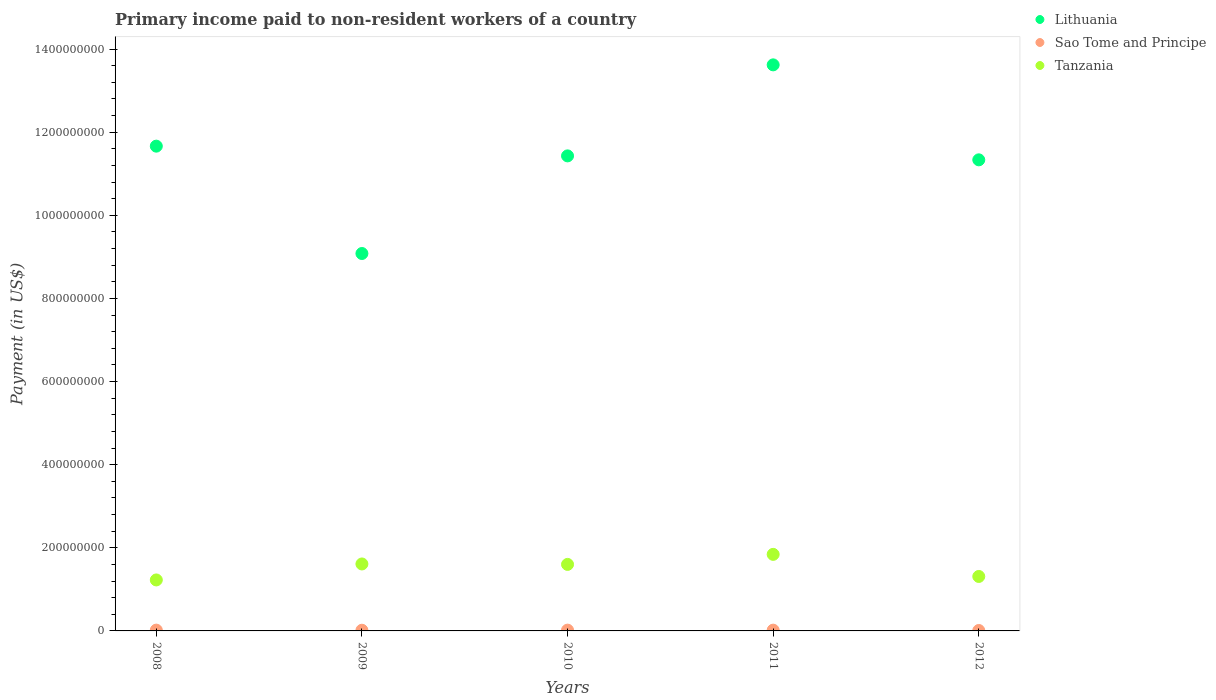Is the number of dotlines equal to the number of legend labels?
Your response must be concise. Yes. What is the amount paid to workers in Lithuania in 2009?
Offer a terse response. 9.08e+08. Across all years, what is the maximum amount paid to workers in Lithuania?
Offer a very short reply. 1.36e+09. Across all years, what is the minimum amount paid to workers in Sao Tome and Principe?
Make the answer very short. 1.02e+06. In which year was the amount paid to workers in Sao Tome and Principe maximum?
Provide a short and direct response. 2008. In which year was the amount paid to workers in Lithuania minimum?
Your answer should be very brief. 2009. What is the total amount paid to workers in Lithuania in the graph?
Provide a succinct answer. 5.71e+09. What is the difference between the amount paid to workers in Lithuania in 2008 and that in 2011?
Your answer should be compact. -1.96e+08. What is the difference between the amount paid to workers in Lithuania in 2008 and the amount paid to workers in Sao Tome and Principe in 2009?
Your response must be concise. 1.16e+09. What is the average amount paid to workers in Tanzania per year?
Your answer should be compact. 1.52e+08. In the year 2009, what is the difference between the amount paid to workers in Tanzania and amount paid to workers in Lithuania?
Offer a very short reply. -7.47e+08. In how many years, is the amount paid to workers in Tanzania greater than 80000000 US$?
Give a very brief answer. 5. What is the ratio of the amount paid to workers in Sao Tome and Principe in 2010 to that in 2012?
Provide a succinct answer. 1.86. Is the difference between the amount paid to workers in Tanzania in 2009 and 2012 greater than the difference between the amount paid to workers in Lithuania in 2009 and 2012?
Make the answer very short. Yes. What is the difference between the highest and the second highest amount paid to workers in Lithuania?
Give a very brief answer. 1.96e+08. What is the difference between the highest and the lowest amount paid to workers in Tanzania?
Make the answer very short. 6.15e+07. In how many years, is the amount paid to workers in Tanzania greater than the average amount paid to workers in Tanzania taken over all years?
Your answer should be compact. 3. Is the amount paid to workers in Lithuania strictly less than the amount paid to workers in Sao Tome and Principe over the years?
Your answer should be very brief. No. How many dotlines are there?
Your answer should be compact. 3. How many years are there in the graph?
Provide a succinct answer. 5. Does the graph contain grids?
Offer a terse response. No. Where does the legend appear in the graph?
Ensure brevity in your answer.  Top right. What is the title of the graph?
Provide a short and direct response. Primary income paid to non-resident workers of a country. What is the label or title of the X-axis?
Make the answer very short. Years. What is the label or title of the Y-axis?
Your answer should be very brief. Payment (in US$). What is the Payment (in US$) in Lithuania in 2008?
Make the answer very short. 1.17e+09. What is the Payment (in US$) of Sao Tome and Principe in 2008?
Keep it short and to the point. 1.94e+06. What is the Payment (in US$) in Tanzania in 2008?
Offer a very short reply. 1.23e+08. What is the Payment (in US$) of Lithuania in 2009?
Keep it short and to the point. 9.08e+08. What is the Payment (in US$) in Sao Tome and Principe in 2009?
Your answer should be compact. 1.64e+06. What is the Payment (in US$) of Tanzania in 2009?
Offer a terse response. 1.61e+08. What is the Payment (in US$) in Lithuania in 2010?
Provide a short and direct response. 1.14e+09. What is the Payment (in US$) of Sao Tome and Principe in 2010?
Ensure brevity in your answer.  1.89e+06. What is the Payment (in US$) of Tanzania in 2010?
Offer a terse response. 1.60e+08. What is the Payment (in US$) of Lithuania in 2011?
Keep it short and to the point. 1.36e+09. What is the Payment (in US$) of Sao Tome and Principe in 2011?
Provide a succinct answer. 1.87e+06. What is the Payment (in US$) in Tanzania in 2011?
Your response must be concise. 1.84e+08. What is the Payment (in US$) of Lithuania in 2012?
Offer a very short reply. 1.13e+09. What is the Payment (in US$) of Sao Tome and Principe in 2012?
Your answer should be very brief. 1.02e+06. What is the Payment (in US$) in Tanzania in 2012?
Provide a short and direct response. 1.31e+08. Across all years, what is the maximum Payment (in US$) of Lithuania?
Provide a succinct answer. 1.36e+09. Across all years, what is the maximum Payment (in US$) in Sao Tome and Principe?
Your answer should be very brief. 1.94e+06. Across all years, what is the maximum Payment (in US$) in Tanzania?
Ensure brevity in your answer.  1.84e+08. Across all years, what is the minimum Payment (in US$) in Lithuania?
Your response must be concise. 9.08e+08. Across all years, what is the minimum Payment (in US$) in Sao Tome and Principe?
Offer a very short reply. 1.02e+06. Across all years, what is the minimum Payment (in US$) of Tanzania?
Make the answer very short. 1.23e+08. What is the total Payment (in US$) in Lithuania in the graph?
Offer a very short reply. 5.71e+09. What is the total Payment (in US$) in Sao Tome and Principe in the graph?
Provide a short and direct response. 8.37e+06. What is the total Payment (in US$) of Tanzania in the graph?
Give a very brief answer. 7.59e+08. What is the difference between the Payment (in US$) of Lithuania in 2008 and that in 2009?
Your response must be concise. 2.58e+08. What is the difference between the Payment (in US$) in Sao Tome and Principe in 2008 and that in 2009?
Your answer should be compact. 2.96e+05. What is the difference between the Payment (in US$) in Tanzania in 2008 and that in 2009?
Ensure brevity in your answer.  -3.85e+07. What is the difference between the Payment (in US$) in Lithuania in 2008 and that in 2010?
Ensure brevity in your answer.  2.34e+07. What is the difference between the Payment (in US$) in Sao Tome and Principe in 2008 and that in 2010?
Offer a terse response. 4.46e+04. What is the difference between the Payment (in US$) of Tanzania in 2008 and that in 2010?
Give a very brief answer. -3.74e+07. What is the difference between the Payment (in US$) of Lithuania in 2008 and that in 2011?
Make the answer very short. -1.96e+08. What is the difference between the Payment (in US$) in Sao Tome and Principe in 2008 and that in 2011?
Provide a short and direct response. 7.24e+04. What is the difference between the Payment (in US$) in Tanzania in 2008 and that in 2011?
Offer a very short reply. -6.15e+07. What is the difference between the Payment (in US$) in Lithuania in 2008 and that in 2012?
Keep it short and to the point. 3.29e+07. What is the difference between the Payment (in US$) in Sao Tome and Principe in 2008 and that in 2012?
Keep it short and to the point. 9.18e+05. What is the difference between the Payment (in US$) of Tanzania in 2008 and that in 2012?
Make the answer very short. -8.38e+06. What is the difference between the Payment (in US$) in Lithuania in 2009 and that in 2010?
Provide a short and direct response. -2.35e+08. What is the difference between the Payment (in US$) in Sao Tome and Principe in 2009 and that in 2010?
Make the answer very short. -2.51e+05. What is the difference between the Payment (in US$) in Tanzania in 2009 and that in 2010?
Offer a terse response. 1.07e+06. What is the difference between the Payment (in US$) in Lithuania in 2009 and that in 2011?
Keep it short and to the point. -4.54e+08. What is the difference between the Payment (in US$) in Sao Tome and Principe in 2009 and that in 2011?
Ensure brevity in your answer.  -2.24e+05. What is the difference between the Payment (in US$) of Tanzania in 2009 and that in 2011?
Provide a short and direct response. -2.31e+07. What is the difference between the Payment (in US$) in Lithuania in 2009 and that in 2012?
Offer a very short reply. -2.25e+08. What is the difference between the Payment (in US$) in Sao Tome and Principe in 2009 and that in 2012?
Your response must be concise. 6.22e+05. What is the difference between the Payment (in US$) in Tanzania in 2009 and that in 2012?
Offer a very short reply. 3.01e+07. What is the difference between the Payment (in US$) of Lithuania in 2010 and that in 2011?
Provide a succinct answer. -2.19e+08. What is the difference between the Payment (in US$) in Sao Tome and Principe in 2010 and that in 2011?
Ensure brevity in your answer.  2.78e+04. What is the difference between the Payment (in US$) of Tanzania in 2010 and that in 2011?
Offer a very short reply. -2.41e+07. What is the difference between the Payment (in US$) of Lithuania in 2010 and that in 2012?
Your answer should be very brief. 9.50e+06. What is the difference between the Payment (in US$) of Sao Tome and Principe in 2010 and that in 2012?
Keep it short and to the point. 8.74e+05. What is the difference between the Payment (in US$) in Tanzania in 2010 and that in 2012?
Your answer should be very brief. 2.90e+07. What is the difference between the Payment (in US$) of Lithuania in 2011 and that in 2012?
Make the answer very short. 2.29e+08. What is the difference between the Payment (in US$) in Sao Tome and Principe in 2011 and that in 2012?
Your answer should be compact. 8.46e+05. What is the difference between the Payment (in US$) of Tanzania in 2011 and that in 2012?
Make the answer very short. 5.31e+07. What is the difference between the Payment (in US$) in Lithuania in 2008 and the Payment (in US$) in Sao Tome and Principe in 2009?
Keep it short and to the point. 1.16e+09. What is the difference between the Payment (in US$) in Lithuania in 2008 and the Payment (in US$) in Tanzania in 2009?
Your response must be concise. 1.01e+09. What is the difference between the Payment (in US$) in Sao Tome and Principe in 2008 and the Payment (in US$) in Tanzania in 2009?
Your response must be concise. -1.59e+08. What is the difference between the Payment (in US$) of Lithuania in 2008 and the Payment (in US$) of Sao Tome and Principe in 2010?
Your answer should be compact. 1.16e+09. What is the difference between the Payment (in US$) in Lithuania in 2008 and the Payment (in US$) in Tanzania in 2010?
Offer a very short reply. 1.01e+09. What is the difference between the Payment (in US$) in Sao Tome and Principe in 2008 and the Payment (in US$) in Tanzania in 2010?
Ensure brevity in your answer.  -1.58e+08. What is the difference between the Payment (in US$) of Lithuania in 2008 and the Payment (in US$) of Sao Tome and Principe in 2011?
Your answer should be very brief. 1.16e+09. What is the difference between the Payment (in US$) of Lithuania in 2008 and the Payment (in US$) of Tanzania in 2011?
Make the answer very short. 9.82e+08. What is the difference between the Payment (in US$) in Sao Tome and Principe in 2008 and the Payment (in US$) in Tanzania in 2011?
Ensure brevity in your answer.  -1.82e+08. What is the difference between the Payment (in US$) of Lithuania in 2008 and the Payment (in US$) of Sao Tome and Principe in 2012?
Ensure brevity in your answer.  1.17e+09. What is the difference between the Payment (in US$) in Lithuania in 2008 and the Payment (in US$) in Tanzania in 2012?
Ensure brevity in your answer.  1.04e+09. What is the difference between the Payment (in US$) in Sao Tome and Principe in 2008 and the Payment (in US$) in Tanzania in 2012?
Give a very brief answer. -1.29e+08. What is the difference between the Payment (in US$) of Lithuania in 2009 and the Payment (in US$) of Sao Tome and Principe in 2010?
Your answer should be very brief. 9.06e+08. What is the difference between the Payment (in US$) of Lithuania in 2009 and the Payment (in US$) of Tanzania in 2010?
Your answer should be very brief. 7.48e+08. What is the difference between the Payment (in US$) of Sao Tome and Principe in 2009 and the Payment (in US$) of Tanzania in 2010?
Make the answer very short. -1.58e+08. What is the difference between the Payment (in US$) of Lithuania in 2009 and the Payment (in US$) of Sao Tome and Principe in 2011?
Provide a succinct answer. 9.06e+08. What is the difference between the Payment (in US$) in Lithuania in 2009 and the Payment (in US$) in Tanzania in 2011?
Keep it short and to the point. 7.24e+08. What is the difference between the Payment (in US$) in Sao Tome and Principe in 2009 and the Payment (in US$) in Tanzania in 2011?
Keep it short and to the point. -1.83e+08. What is the difference between the Payment (in US$) of Lithuania in 2009 and the Payment (in US$) of Sao Tome and Principe in 2012?
Make the answer very short. 9.07e+08. What is the difference between the Payment (in US$) of Lithuania in 2009 and the Payment (in US$) of Tanzania in 2012?
Offer a very short reply. 7.77e+08. What is the difference between the Payment (in US$) of Sao Tome and Principe in 2009 and the Payment (in US$) of Tanzania in 2012?
Your response must be concise. -1.29e+08. What is the difference between the Payment (in US$) of Lithuania in 2010 and the Payment (in US$) of Sao Tome and Principe in 2011?
Your response must be concise. 1.14e+09. What is the difference between the Payment (in US$) of Lithuania in 2010 and the Payment (in US$) of Tanzania in 2011?
Your answer should be very brief. 9.59e+08. What is the difference between the Payment (in US$) of Sao Tome and Principe in 2010 and the Payment (in US$) of Tanzania in 2011?
Your answer should be compact. -1.82e+08. What is the difference between the Payment (in US$) in Lithuania in 2010 and the Payment (in US$) in Sao Tome and Principe in 2012?
Ensure brevity in your answer.  1.14e+09. What is the difference between the Payment (in US$) in Lithuania in 2010 and the Payment (in US$) in Tanzania in 2012?
Keep it short and to the point. 1.01e+09. What is the difference between the Payment (in US$) in Sao Tome and Principe in 2010 and the Payment (in US$) in Tanzania in 2012?
Provide a short and direct response. -1.29e+08. What is the difference between the Payment (in US$) in Lithuania in 2011 and the Payment (in US$) in Sao Tome and Principe in 2012?
Ensure brevity in your answer.  1.36e+09. What is the difference between the Payment (in US$) in Lithuania in 2011 and the Payment (in US$) in Tanzania in 2012?
Your response must be concise. 1.23e+09. What is the difference between the Payment (in US$) in Sao Tome and Principe in 2011 and the Payment (in US$) in Tanzania in 2012?
Ensure brevity in your answer.  -1.29e+08. What is the average Payment (in US$) of Lithuania per year?
Provide a short and direct response. 1.14e+09. What is the average Payment (in US$) of Sao Tome and Principe per year?
Keep it short and to the point. 1.67e+06. What is the average Payment (in US$) of Tanzania per year?
Ensure brevity in your answer.  1.52e+08. In the year 2008, what is the difference between the Payment (in US$) of Lithuania and Payment (in US$) of Sao Tome and Principe?
Your answer should be compact. 1.16e+09. In the year 2008, what is the difference between the Payment (in US$) in Lithuania and Payment (in US$) in Tanzania?
Provide a succinct answer. 1.04e+09. In the year 2008, what is the difference between the Payment (in US$) in Sao Tome and Principe and Payment (in US$) in Tanzania?
Give a very brief answer. -1.21e+08. In the year 2009, what is the difference between the Payment (in US$) of Lithuania and Payment (in US$) of Sao Tome and Principe?
Provide a succinct answer. 9.07e+08. In the year 2009, what is the difference between the Payment (in US$) in Lithuania and Payment (in US$) in Tanzania?
Give a very brief answer. 7.47e+08. In the year 2009, what is the difference between the Payment (in US$) of Sao Tome and Principe and Payment (in US$) of Tanzania?
Make the answer very short. -1.59e+08. In the year 2010, what is the difference between the Payment (in US$) in Lithuania and Payment (in US$) in Sao Tome and Principe?
Your response must be concise. 1.14e+09. In the year 2010, what is the difference between the Payment (in US$) of Lithuania and Payment (in US$) of Tanzania?
Provide a succinct answer. 9.83e+08. In the year 2010, what is the difference between the Payment (in US$) of Sao Tome and Principe and Payment (in US$) of Tanzania?
Your answer should be very brief. -1.58e+08. In the year 2011, what is the difference between the Payment (in US$) of Lithuania and Payment (in US$) of Sao Tome and Principe?
Make the answer very short. 1.36e+09. In the year 2011, what is the difference between the Payment (in US$) in Lithuania and Payment (in US$) in Tanzania?
Your answer should be very brief. 1.18e+09. In the year 2011, what is the difference between the Payment (in US$) of Sao Tome and Principe and Payment (in US$) of Tanzania?
Your response must be concise. -1.82e+08. In the year 2012, what is the difference between the Payment (in US$) of Lithuania and Payment (in US$) of Sao Tome and Principe?
Ensure brevity in your answer.  1.13e+09. In the year 2012, what is the difference between the Payment (in US$) of Lithuania and Payment (in US$) of Tanzania?
Your answer should be very brief. 1.00e+09. In the year 2012, what is the difference between the Payment (in US$) of Sao Tome and Principe and Payment (in US$) of Tanzania?
Your response must be concise. -1.30e+08. What is the ratio of the Payment (in US$) in Lithuania in 2008 to that in 2009?
Ensure brevity in your answer.  1.28. What is the ratio of the Payment (in US$) in Sao Tome and Principe in 2008 to that in 2009?
Offer a terse response. 1.18. What is the ratio of the Payment (in US$) of Tanzania in 2008 to that in 2009?
Your response must be concise. 0.76. What is the ratio of the Payment (in US$) of Lithuania in 2008 to that in 2010?
Provide a short and direct response. 1.02. What is the ratio of the Payment (in US$) in Sao Tome and Principe in 2008 to that in 2010?
Give a very brief answer. 1.02. What is the ratio of the Payment (in US$) in Tanzania in 2008 to that in 2010?
Offer a terse response. 0.77. What is the ratio of the Payment (in US$) of Lithuania in 2008 to that in 2011?
Keep it short and to the point. 0.86. What is the ratio of the Payment (in US$) in Sao Tome and Principe in 2008 to that in 2011?
Offer a terse response. 1.04. What is the ratio of the Payment (in US$) in Tanzania in 2008 to that in 2011?
Keep it short and to the point. 0.67. What is the ratio of the Payment (in US$) in Lithuania in 2008 to that in 2012?
Provide a succinct answer. 1.03. What is the ratio of the Payment (in US$) of Sao Tome and Principe in 2008 to that in 2012?
Offer a terse response. 1.9. What is the ratio of the Payment (in US$) in Tanzania in 2008 to that in 2012?
Offer a very short reply. 0.94. What is the ratio of the Payment (in US$) of Lithuania in 2009 to that in 2010?
Give a very brief answer. 0.79. What is the ratio of the Payment (in US$) of Sao Tome and Principe in 2009 to that in 2010?
Provide a short and direct response. 0.87. What is the ratio of the Payment (in US$) in Tanzania in 2009 to that in 2010?
Provide a succinct answer. 1.01. What is the ratio of the Payment (in US$) in Sao Tome and Principe in 2009 to that in 2011?
Offer a very short reply. 0.88. What is the ratio of the Payment (in US$) of Tanzania in 2009 to that in 2011?
Your answer should be compact. 0.87. What is the ratio of the Payment (in US$) of Lithuania in 2009 to that in 2012?
Provide a succinct answer. 0.8. What is the ratio of the Payment (in US$) in Sao Tome and Principe in 2009 to that in 2012?
Give a very brief answer. 1.61. What is the ratio of the Payment (in US$) of Tanzania in 2009 to that in 2012?
Offer a very short reply. 1.23. What is the ratio of the Payment (in US$) in Lithuania in 2010 to that in 2011?
Your answer should be very brief. 0.84. What is the ratio of the Payment (in US$) in Sao Tome and Principe in 2010 to that in 2011?
Make the answer very short. 1.01. What is the ratio of the Payment (in US$) of Tanzania in 2010 to that in 2011?
Offer a very short reply. 0.87. What is the ratio of the Payment (in US$) in Lithuania in 2010 to that in 2012?
Make the answer very short. 1.01. What is the ratio of the Payment (in US$) of Sao Tome and Principe in 2010 to that in 2012?
Keep it short and to the point. 1.86. What is the ratio of the Payment (in US$) of Tanzania in 2010 to that in 2012?
Give a very brief answer. 1.22. What is the ratio of the Payment (in US$) of Lithuania in 2011 to that in 2012?
Your response must be concise. 1.2. What is the ratio of the Payment (in US$) of Sao Tome and Principe in 2011 to that in 2012?
Keep it short and to the point. 1.83. What is the ratio of the Payment (in US$) in Tanzania in 2011 to that in 2012?
Ensure brevity in your answer.  1.41. What is the difference between the highest and the second highest Payment (in US$) of Lithuania?
Provide a short and direct response. 1.96e+08. What is the difference between the highest and the second highest Payment (in US$) in Sao Tome and Principe?
Make the answer very short. 4.46e+04. What is the difference between the highest and the second highest Payment (in US$) of Tanzania?
Ensure brevity in your answer.  2.31e+07. What is the difference between the highest and the lowest Payment (in US$) of Lithuania?
Your answer should be very brief. 4.54e+08. What is the difference between the highest and the lowest Payment (in US$) in Sao Tome and Principe?
Make the answer very short. 9.18e+05. What is the difference between the highest and the lowest Payment (in US$) of Tanzania?
Your answer should be very brief. 6.15e+07. 